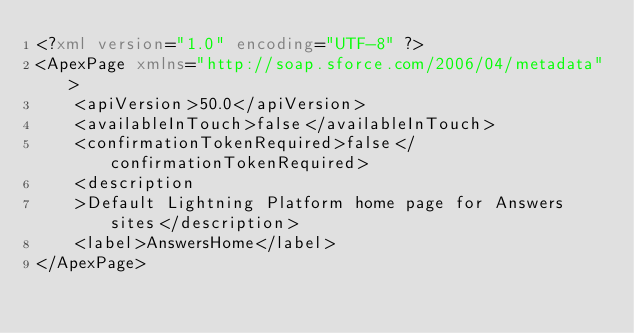Convert code to text. <code><loc_0><loc_0><loc_500><loc_500><_XML_><?xml version="1.0" encoding="UTF-8" ?>
<ApexPage xmlns="http://soap.sforce.com/2006/04/metadata">
    <apiVersion>50.0</apiVersion>
    <availableInTouch>false</availableInTouch>
    <confirmationTokenRequired>false</confirmationTokenRequired>
    <description
    >Default Lightning Platform home page for Answers sites</description>
    <label>AnswersHome</label>
</ApexPage>
</code> 